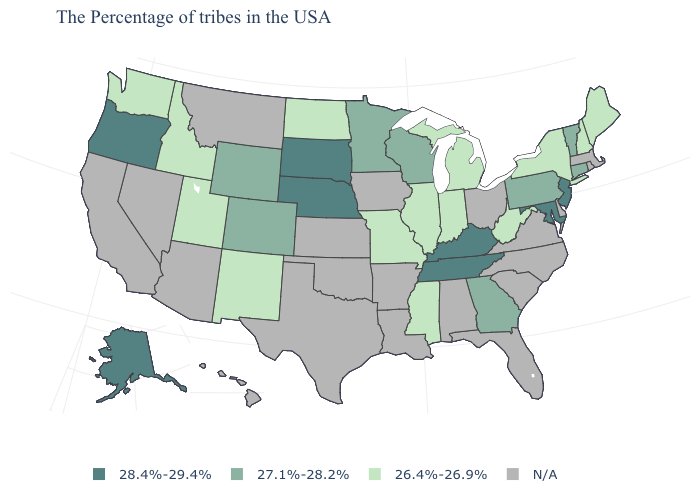Which states have the lowest value in the Northeast?
Concise answer only. Maine, New Hampshire, New York. What is the value of Arizona?
Answer briefly. N/A. Among the states that border Florida , which have the lowest value?
Keep it brief. Georgia. Name the states that have a value in the range N/A?
Answer briefly. Massachusetts, Rhode Island, Delaware, Virginia, North Carolina, South Carolina, Ohio, Florida, Alabama, Louisiana, Arkansas, Iowa, Kansas, Oklahoma, Texas, Montana, Arizona, Nevada, California, Hawaii. Does the first symbol in the legend represent the smallest category?
Quick response, please. No. Does the map have missing data?
Write a very short answer. Yes. Among the states that border Connecticut , which have the lowest value?
Write a very short answer. New York. Name the states that have a value in the range 28.4%-29.4%?
Concise answer only. New Jersey, Maryland, Kentucky, Tennessee, Nebraska, South Dakota, Oregon, Alaska. Name the states that have a value in the range N/A?
Be succinct. Massachusetts, Rhode Island, Delaware, Virginia, North Carolina, South Carolina, Ohio, Florida, Alabama, Louisiana, Arkansas, Iowa, Kansas, Oklahoma, Texas, Montana, Arizona, Nevada, California, Hawaii. What is the value of West Virginia?
Answer briefly. 26.4%-26.9%. Does the map have missing data?
Concise answer only. Yes. What is the value of Georgia?
Answer briefly. 27.1%-28.2%. Name the states that have a value in the range 26.4%-26.9%?
Quick response, please. Maine, New Hampshire, New York, West Virginia, Michigan, Indiana, Illinois, Mississippi, Missouri, North Dakota, New Mexico, Utah, Idaho, Washington. What is the highest value in the Northeast ?
Quick response, please. 28.4%-29.4%. 